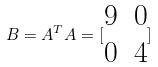Convert formula to latex. <formula><loc_0><loc_0><loc_500><loc_500>B = A ^ { T } A = [ \begin{matrix} 9 & 0 \\ 0 & 4 \end{matrix} ]</formula> 